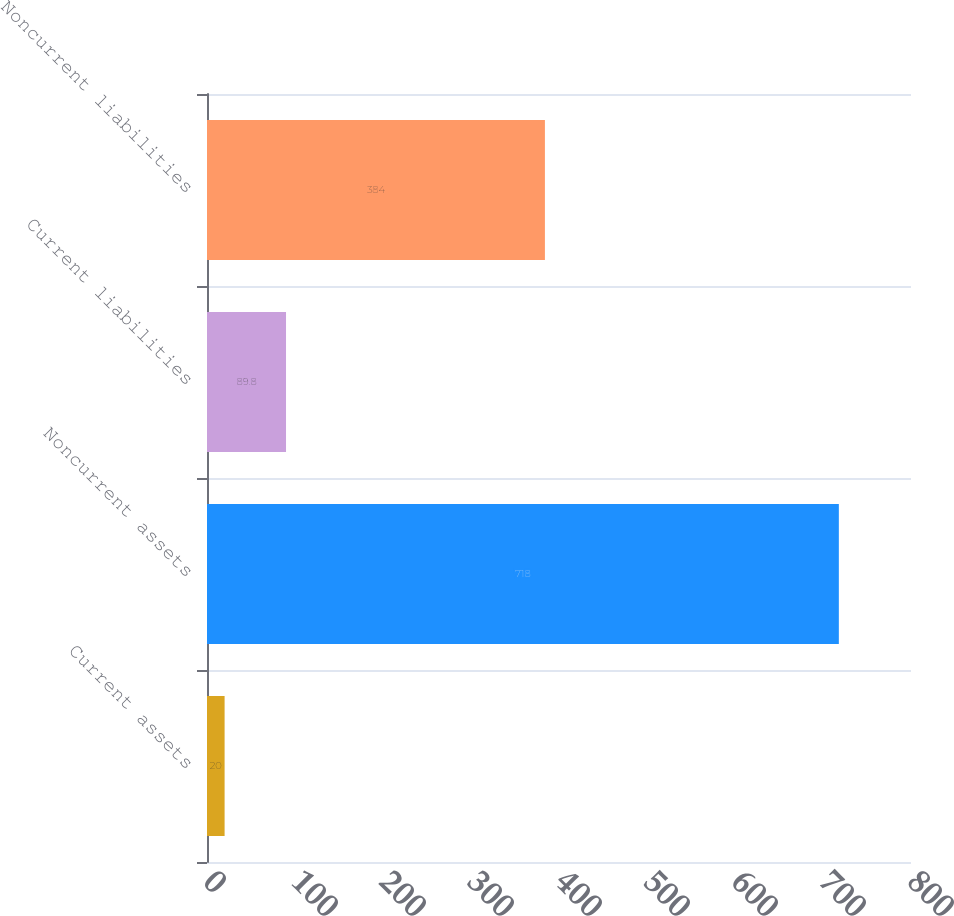<chart> <loc_0><loc_0><loc_500><loc_500><bar_chart><fcel>Current assets<fcel>Noncurrent assets<fcel>Current liabilities<fcel>Noncurrent liabilities<nl><fcel>20<fcel>718<fcel>89.8<fcel>384<nl></chart> 